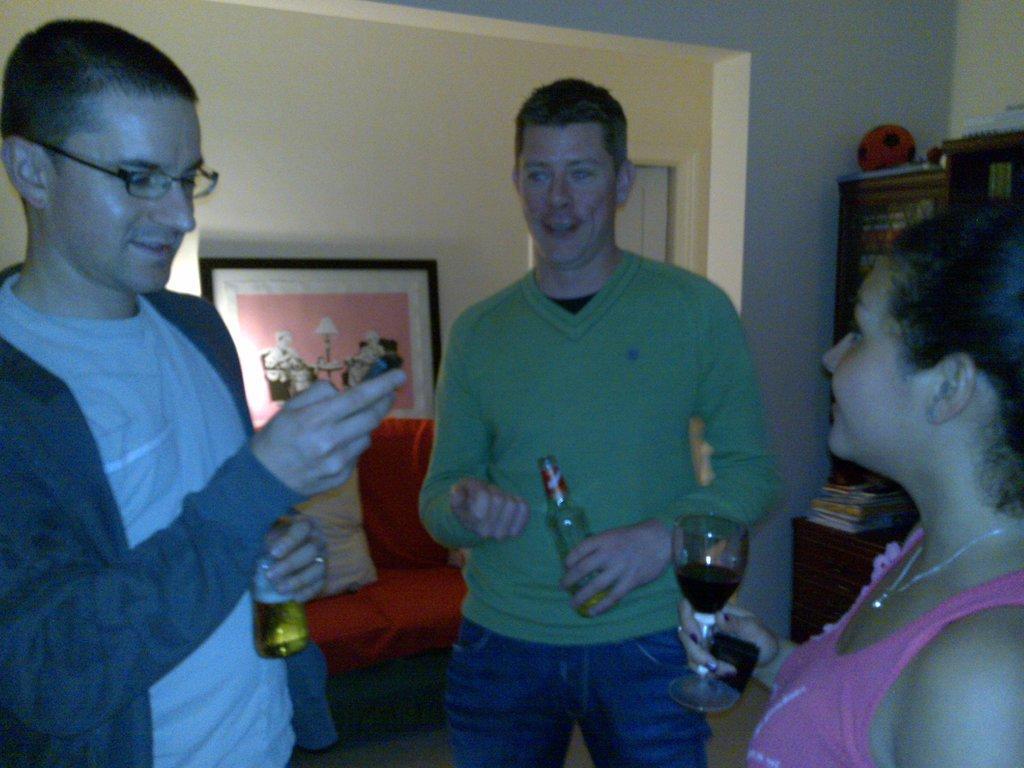Could you give a brief overview of what you see in this image? In this image I can see few persons are standing on the floor. I can see two of them are holding bottles and a woman is holding a glass. In the background I can see the wall, a photo frame attached to the wall, a couch and few other objects. 